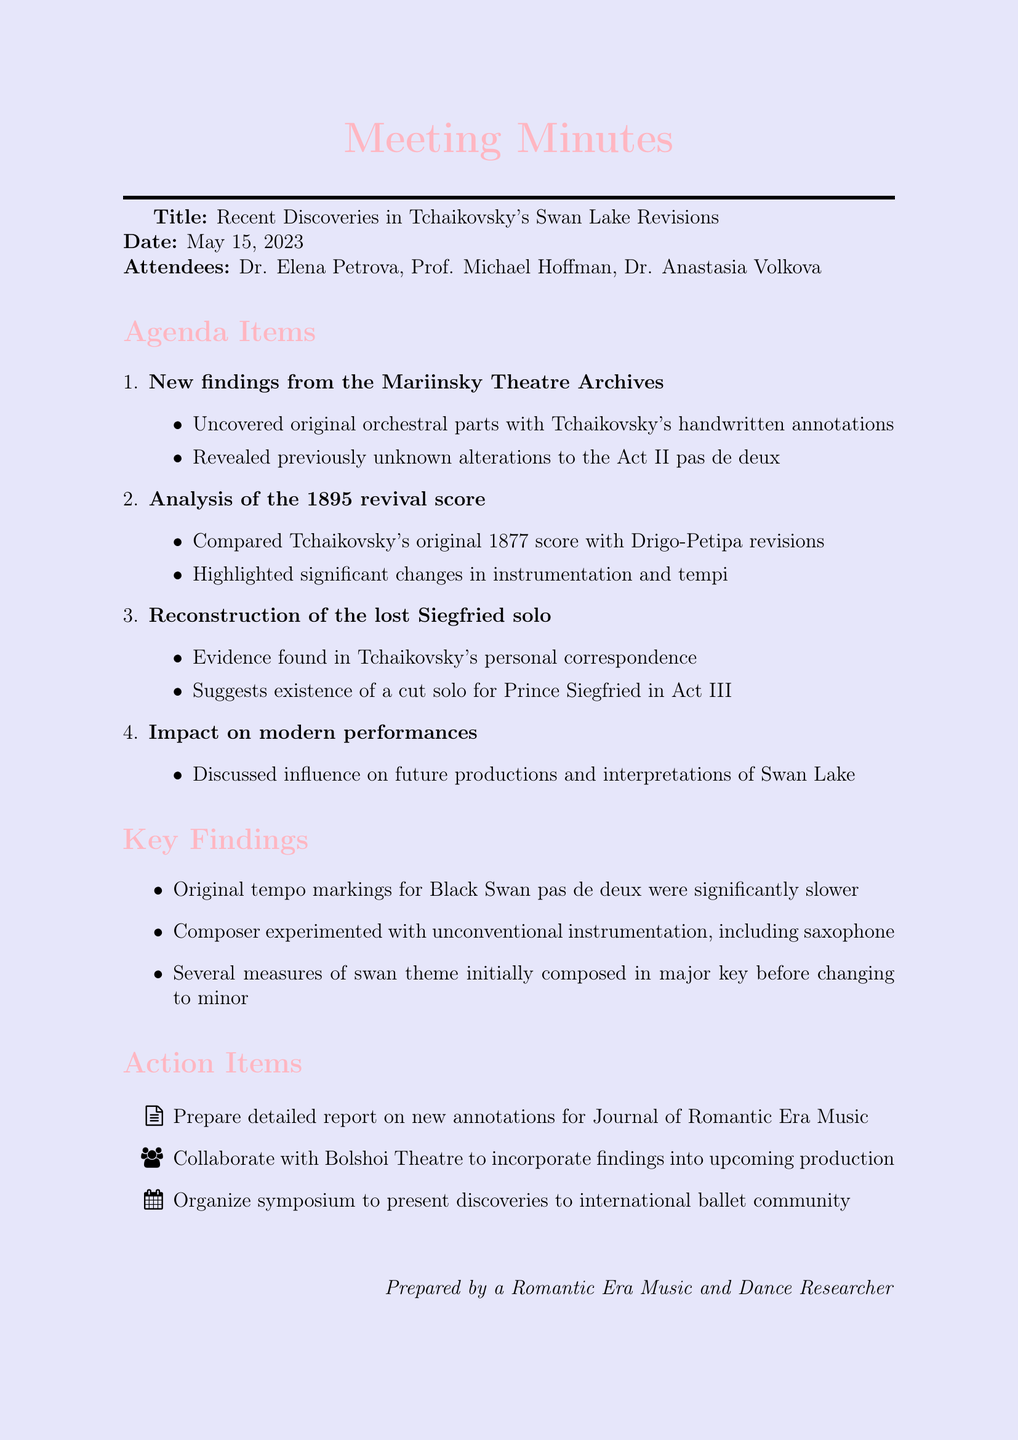What was the date of the meeting? The date of the meeting is explicitly provided at the beginning of the document.
Answer: May 15, 2023 Who was the lead researcher present at the meeting? The document lists attendees, which includes the lead researcher.
Answer: Dr. Elena Petrova What significant changes were highlighted in the analysis of the 1895 revival score? The details of the agenda item specifically mention changes in regard to instrumentation and tempi.
Answer: Instrumentation and tempi What is one finding regarding Tchaikovsky's tempo markings for the Black Swan pas de deux? The key findings section addresses the nature of the original tempo markings in comparison to modern performances.
Answer: Significantly slower Which theatre is mentioned in connection with future collaboration on Swan Lake? One of the action items states the need to collaborate with a specific theater mentioned in the document.
Answer: Bolshoi Theatre What is included in the action items for the meeting? The action items outline steps to be taken following the discoveries discussed at the meeting.
Answer: Prepare a detailed report How did Tchaikovsky experiment with instrumentation in his early drafts? The key findings highlight a particular unconventional instrument used in Tchaikovsky's early drafts.
Answer: Saxophone What was the focus of the agenda item titled "Reconstruction of the lost Siegfried solo"? This item discusses evidence found in Tchaikovsky's correspondence regarding a specific cut solo.
Answer: Existence of a cut solo for Prince Siegfried in Act III 